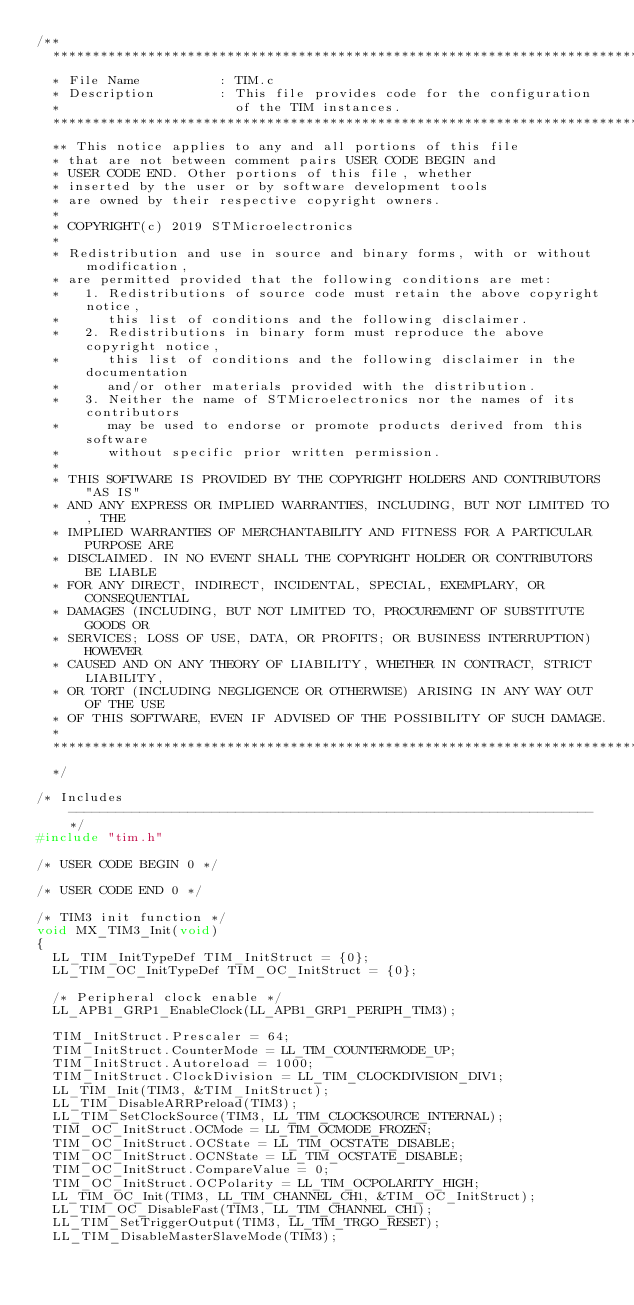<code> <loc_0><loc_0><loc_500><loc_500><_C_>/**
  ******************************************************************************
  * File Name          : TIM.c
  * Description        : This file provides code for the configuration
  *                      of the TIM instances.
  ******************************************************************************
  ** This notice applies to any and all portions of this file
  * that are not between comment pairs USER CODE BEGIN and
  * USER CODE END. Other portions of this file, whether 
  * inserted by the user or by software development tools
  * are owned by their respective copyright owners.
  *
  * COPYRIGHT(c) 2019 STMicroelectronics
  *
  * Redistribution and use in source and binary forms, with or without modification,
  * are permitted provided that the following conditions are met:
  *   1. Redistributions of source code must retain the above copyright notice,
  *      this list of conditions and the following disclaimer.
  *   2. Redistributions in binary form must reproduce the above copyright notice,
  *      this list of conditions and the following disclaimer in the documentation
  *      and/or other materials provided with the distribution.
  *   3. Neither the name of STMicroelectronics nor the names of its contributors
  *      may be used to endorse or promote products derived from this software
  *      without specific prior written permission.
  *
  * THIS SOFTWARE IS PROVIDED BY THE COPYRIGHT HOLDERS AND CONTRIBUTORS "AS IS"
  * AND ANY EXPRESS OR IMPLIED WARRANTIES, INCLUDING, BUT NOT LIMITED TO, THE
  * IMPLIED WARRANTIES OF MERCHANTABILITY AND FITNESS FOR A PARTICULAR PURPOSE ARE
  * DISCLAIMED. IN NO EVENT SHALL THE COPYRIGHT HOLDER OR CONTRIBUTORS BE LIABLE
  * FOR ANY DIRECT, INDIRECT, INCIDENTAL, SPECIAL, EXEMPLARY, OR CONSEQUENTIAL
  * DAMAGES (INCLUDING, BUT NOT LIMITED TO, PROCUREMENT OF SUBSTITUTE GOODS OR
  * SERVICES; LOSS OF USE, DATA, OR PROFITS; OR BUSINESS INTERRUPTION) HOWEVER
  * CAUSED AND ON ANY THEORY OF LIABILITY, WHETHER IN CONTRACT, STRICT LIABILITY,
  * OR TORT (INCLUDING NEGLIGENCE OR OTHERWISE) ARISING IN ANY WAY OUT OF THE USE
  * OF THIS SOFTWARE, EVEN IF ADVISED OF THE POSSIBILITY OF SUCH DAMAGE.
  *
  ******************************************************************************
  */

/* Includes ------------------------------------------------------------------*/
#include "tim.h"

/* USER CODE BEGIN 0 */

/* USER CODE END 0 */

/* TIM3 init function */
void MX_TIM3_Init(void)
{
  LL_TIM_InitTypeDef TIM_InitStruct = {0};
  LL_TIM_OC_InitTypeDef TIM_OC_InitStruct = {0};

  /* Peripheral clock enable */
  LL_APB1_GRP1_EnableClock(LL_APB1_GRP1_PERIPH_TIM3);

  TIM_InitStruct.Prescaler = 64;
  TIM_InitStruct.CounterMode = LL_TIM_COUNTERMODE_UP;
  TIM_InitStruct.Autoreload = 1000;
  TIM_InitStruct.ClockDivision = LL_TIM_CLOCKDIVISION_DIV1;
  LL_TIM_Init(TIM3, &TIM_InitStruct);
  LL_TIM_DisableARRPreload(TIM3);
  LL_TIM_SetClockSource(TIM3, LL_TIM_CLOCKSOURCE_INTERNAL);
  TIM_OC_InitStruct.OCMode = LL_TIM_OCMODE_FROZEN;
  TIM_OC_InitStruct.OCState = LL_TIM_OCSTATE_DISABLE;
  TIM_OC_InitStruct.OCNState = LL_TIM_OCSTATE_DISABLE;
  TIM_OC_InitStruct.CompareValue = 0;
  TIM_OC_InitStruct.OCPolarity = LL_TIM_OCPOLARITY_HIGH;
  LL_TIM_OC_Init(TIM3, LL_TIM_CHANNEL_CH1, &TIM_OC_InitStruct);
  LL_TIM_OC_DisableFast(TIM3, LL_TIM_CHANNEL_CH1);
  LL_TIM_SetTriggerOutput(TIM3, LL_TIM_TRGO_RESET);
  LL_TIM_DisableMasterSlaveMode(TIM3);
</code> 